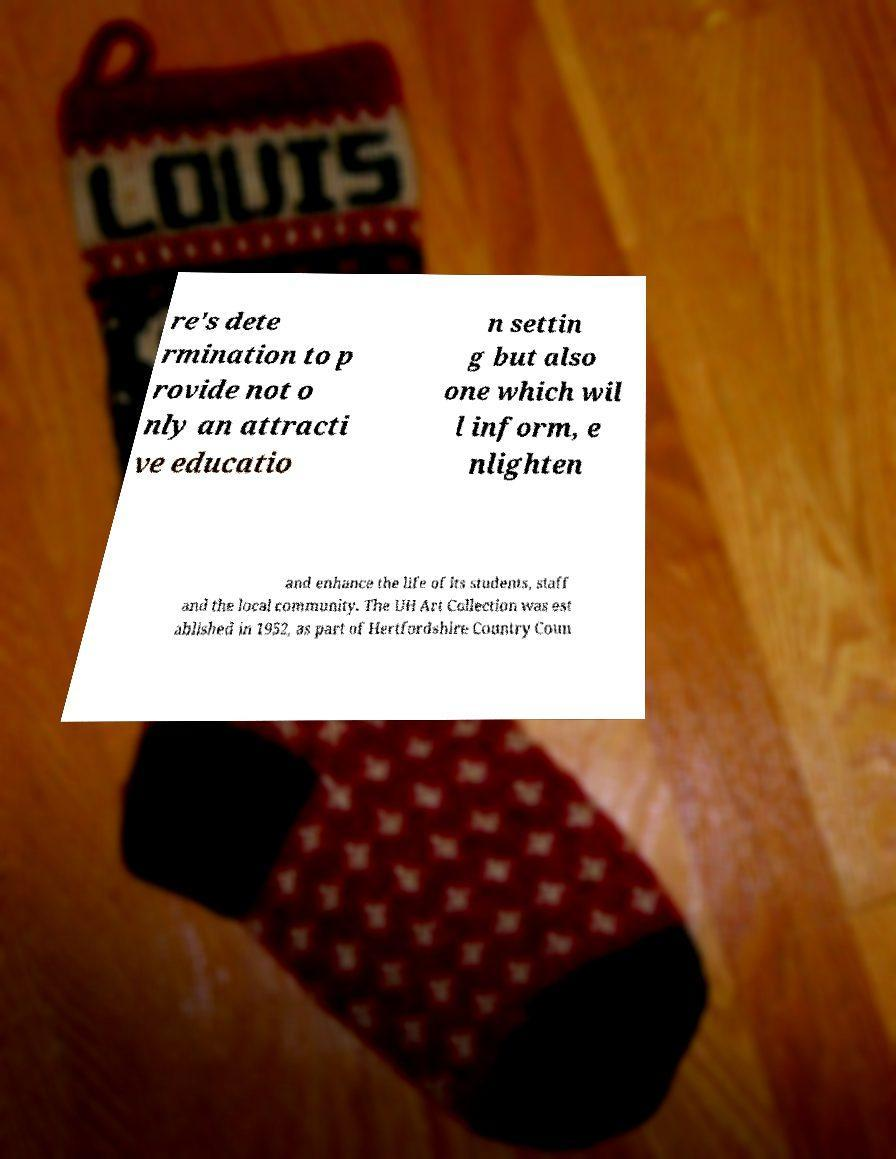Please read and relay the text visible in this image. What does it say? re's dete rmination to p rovide not o nly an attracti ve educatio n settin g but also one which wil l inform, e nlighten and enhance the life of its students, staff and the local community. The UH Art Collection was est ablished in 1952, as part of Hertfordshire Country Coun 